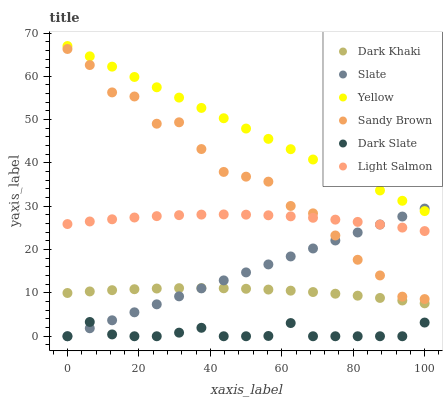Does Dark Slate have the minimum area under the curve?
Answer yes or no. Yes. Does Yellow have the maximum area under the curve?
Answer yes or no. Yes. Does Slate have the minimum area under the curve?
Answer yes or no. No. Does Slate have the maximum area under the curve?
Answer yes or no. No. Is Slate the smoothest?
Answer yes or no. Yes. Is Sandy Brown the roughest?
Answer yes or no. Yes. Is Yellow the smoothest?
Answer yes or no. No. Is Yellow the roughest?
Answer yes or no. No. Does Slate have the lowest value?
Answer yes or no. Yes. Does Yellow have the lowest value?
Answer yes or no. No. Does Yellow have the highest value?
Answer yes or no. Yes. Does Slate have the highest value?
Answer yes or no. No. Is Dark Slate less than Dark Khaki?
Answer yes or no. Yes. Is Sandy Brown greater than Dark Slate?
Answer yes or no. Yes. Does Slate intersect Dark Khaki?
Answer yes or no. Yes. Is Slate less than Dark Khaki?
Answer yes or no. No. Is Slate greater than Dark Khaki?
Answer yes or no. No. Does Dark Slate intersect Dark Khaki?
Answer yes or no. No. 